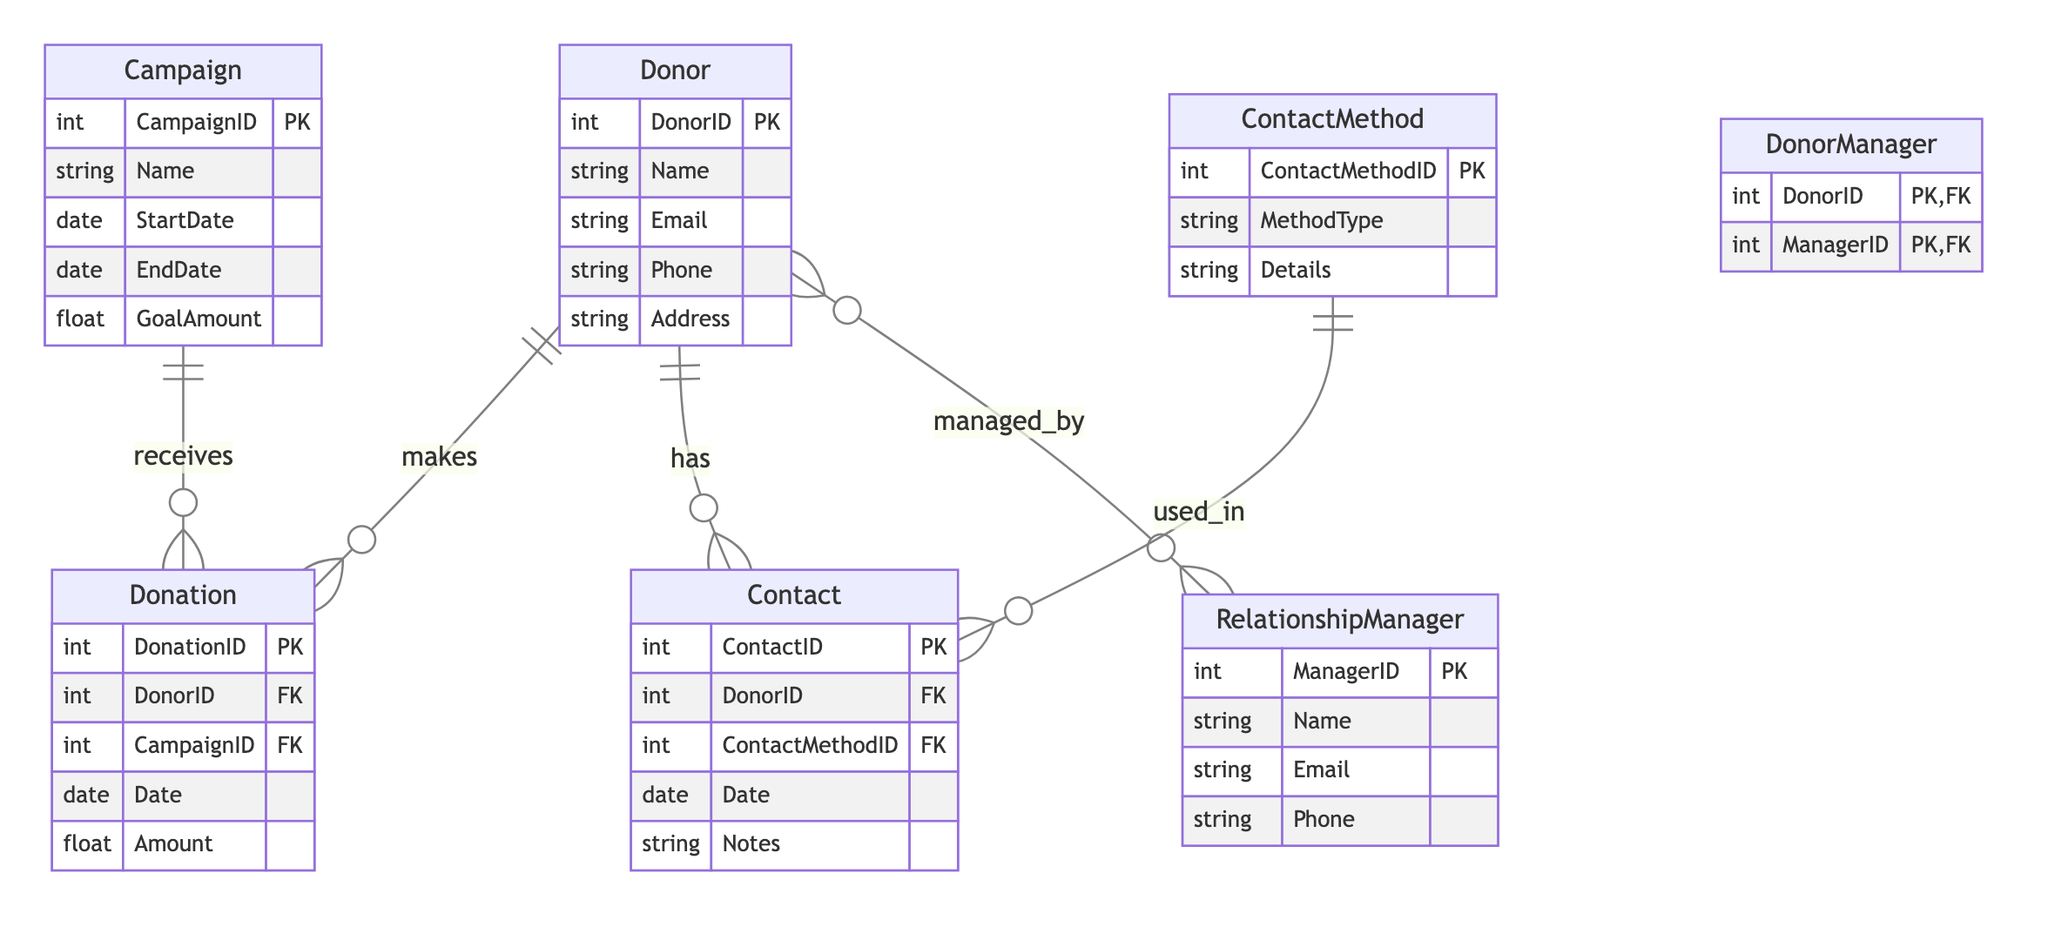What is the primary key of the Donor entity? The primary key of the Donor entity is DonorID, which uniquely identifies each donor in the system.
Answer: DonorID How many attributes does the Campaign entity have? The Campaign entity has five attributes: CampaignID, Name, StartDate, EndDate, and GoalAmount.
Answer: Five What type of relationship exists between Donor and Donation? The relationship between Donor and Donation is One to Many, meaning one donor can make multiple donations.
Answer: One to Many Which contact method entity is used in the Contact entity? The entity used in the Contact entity is ContactMethod, indicating that each contact entry references a specific communication method.
Answer: ContactMethod What is the name of the join entity for the many-to-many relationship between Donor and Relationship Manager? The join entity that connects the many-to-many relationship between Donor and Relationship Manager is DonorManager.
Answer: DonorManager How many foreign keys does the Donation entity have? The Donation entity has two foreign keys: DonorID and CampaignID. These keys create relationships with the Donor and Campaign entities respectively.
Answer: Two Which entity details can be found in ContactMethod? The ContactMethod entity provides the attributes MethodType and Details, which describe how donors are contacted.
Answer: MethodType, Details How are the Donation and Campaign entities related? The Donation entity receives its association from the Campaign entity through a One to Many relationship, indicating that each campaign can receive many donations.
Answer: One to Many What is the primary key of the Contact entity? The primary key of the Contact entity is ContactID, which uniquely identifies each contact record linked to donors.
Answer: ContactID 